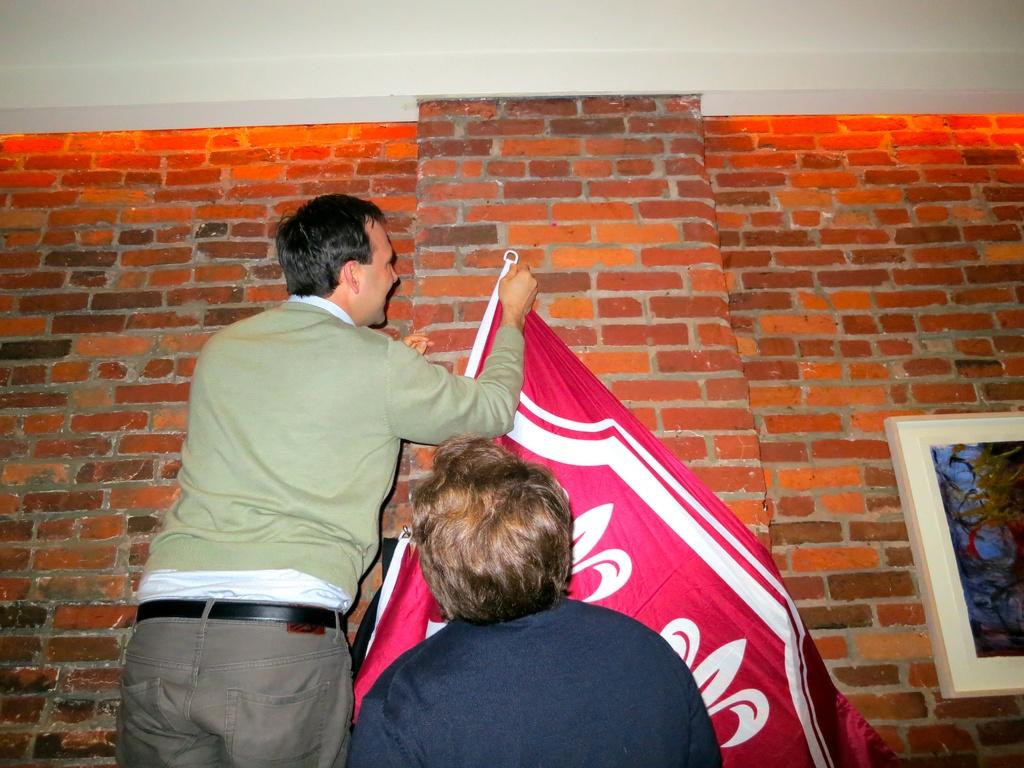What is the man in the center of the image doing? The man is holding a flag in the center of the image. Can you describe the person at the bottom of the image? There is a person at the bottom of the image, but no specific details are provided. What can be seen in the background of the image? There is a photo frame and a wall in the background of the image. What type of knot is the minister using to secure the line in the image? There is no minister, knot, or line present in the image. 